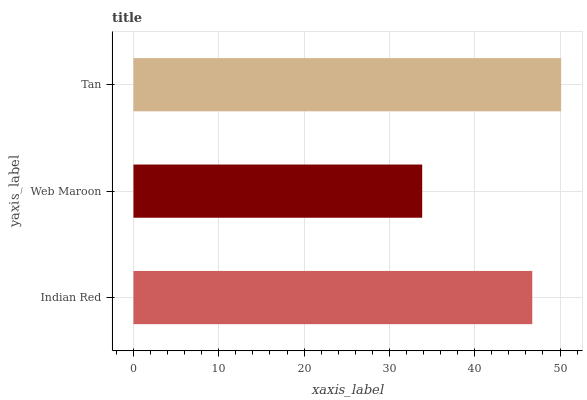Is Web Maroon the minimum?
Answer yes or no. Yes. Is Tan the maximum?
Answer yes or no. Yes. Is Tan the minimum?
Answer yes or no. No. Is Web Maroon the maximum?
Answer yes or no. No. Is Tan greater than Web Maroon?
Answer yes or no. Yes. Is Web Maroon less than Tan?
Answer yes or no. Yes. Is Web Maroon greater than Tan?
Answer yes or no. No. Is Tan less than Web Maroon?
Answer yes or no. No. Is Indian Red the high median?
Answer yes or no. Yes. Is Indian Red the low median?
Answer yes or no. Yes. Is Web Maroon the high median?
Answer yes or no. No. Is Tan the low median?
Answer yes or no. No. 